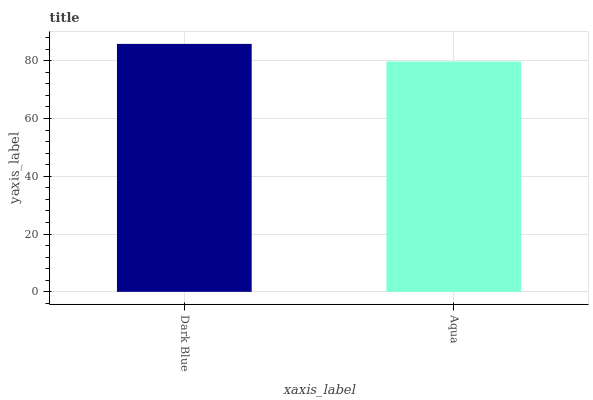Is Aqua the minimum?
Answer yes or no. Yes. Is Dark Blue the maximum?
Answer yes or no. Yes. Is Aqua the maximum?
Answer yes or no. No. Is Dark Blue greater than Aqua?
Answer yes or no. Yes. Is Aqua less than Dark Blue?
Answer yes or no. Yes. Is Aqua greater than Dark Blue?
Answer yes or no. No. Is Dark Blue less than Aqua?
Answer yes or no. No. Is Dark Blue the high median?
Answer yes or no. Yes. Is Aqua the low median?
Answer yes or no. Yes. Is Aqua the high median?
Answer yes or no. No. Is Dark Blue the low median?
Answer yes or no. No. 